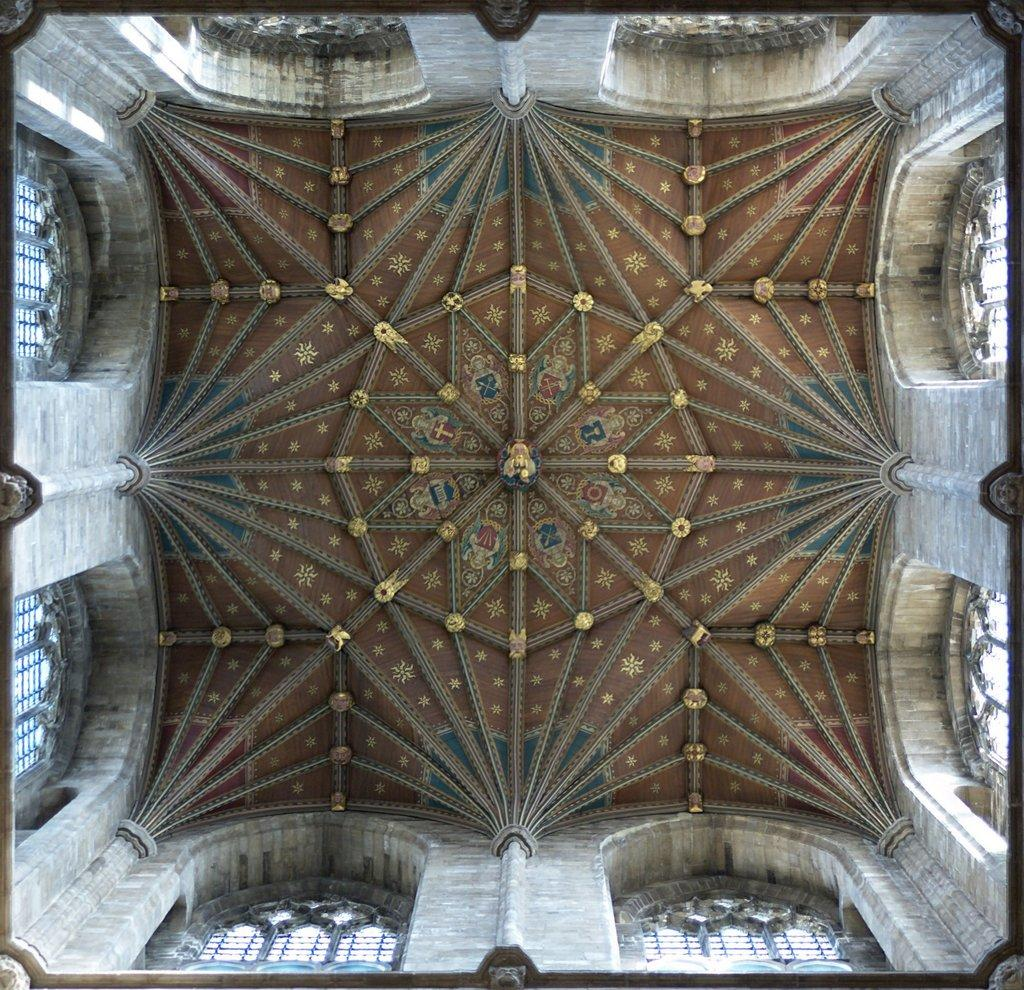What type of location is depicted in the image? The image shows an inside view of a building. What architectural features can be seen in the image? Pillars are present in the image. What part of the building is visible in the image? The roof of the building is visible in the image. How can natural light enter the building in the image? Windows are visible in the image, which allows natural light to enter. What type of egg is being sold at the market in the image? There is no market or egg present in the image; it shows an inside view of a building with architectural features such as pillars, windows, and a visible roof. 